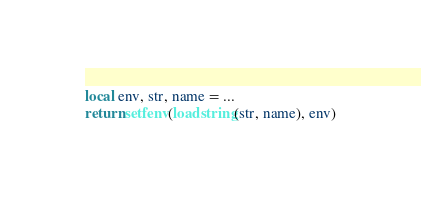Convert code to text. <code><loc_0><loc_0><loc_500><loc_500><_Lua_>local env, str, name = ...
return setfenv(loadstring(str, name), env)
</code> 